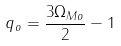<formula> <loc_0><loc_0><loc_500><loc_500>q _ { o } = \frac { 3 \Omega _ { M o } } { 2 } - 1</formula> 